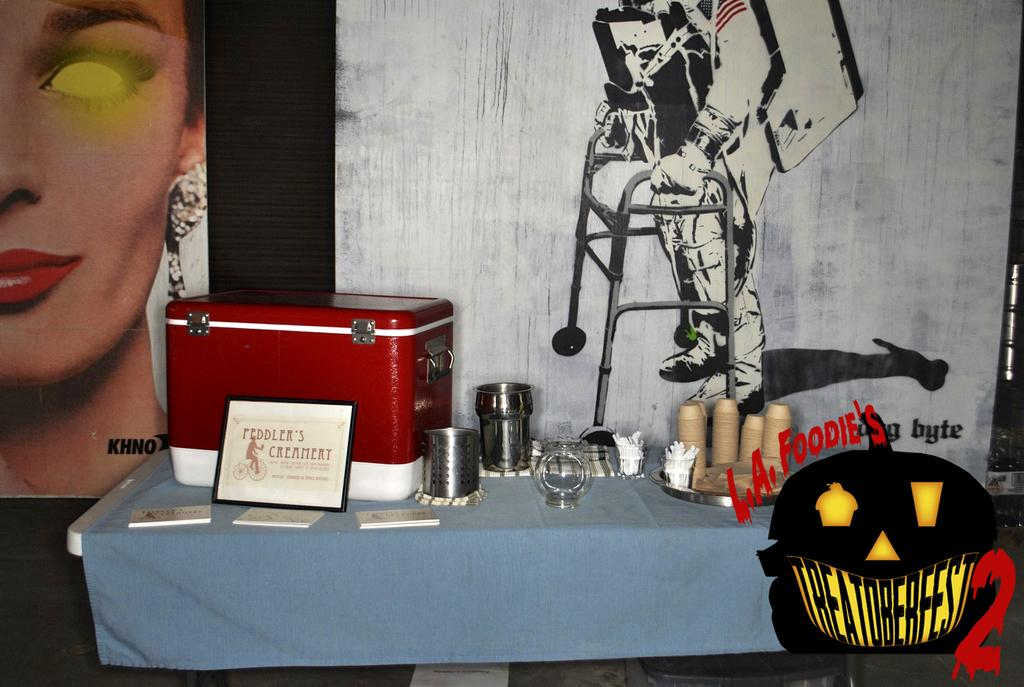Provide a one-sentence caption for the provided image. a display from Feddler's Creamery in front of a disabled astronaut poster. 